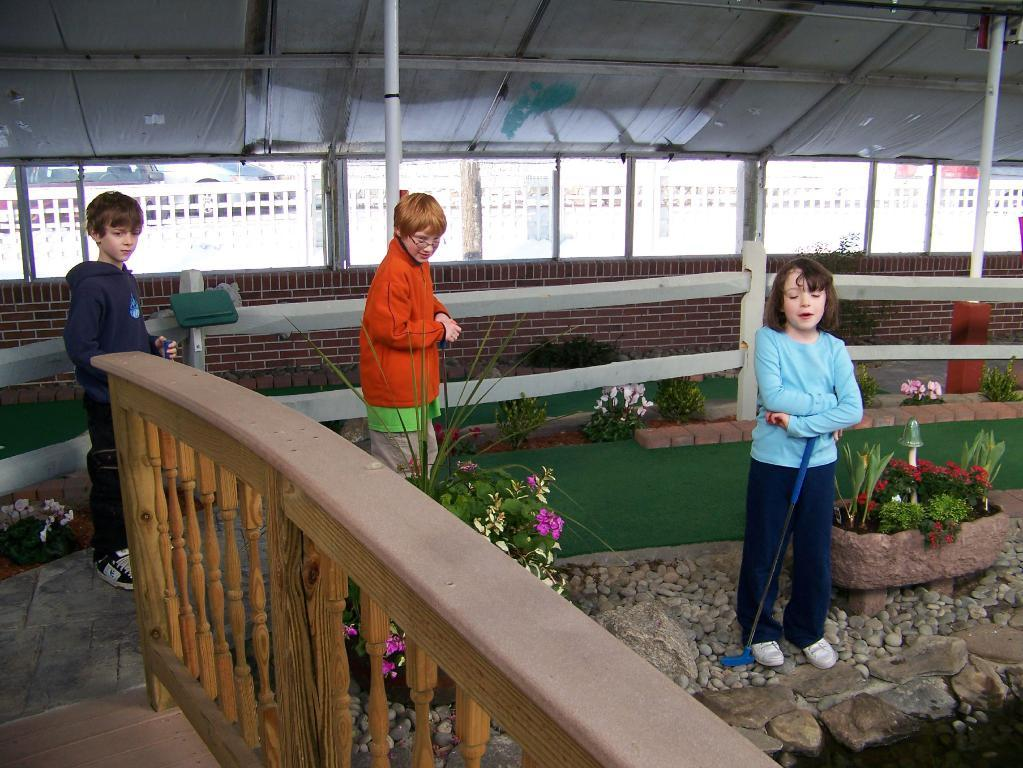How many children are in the image? There are three children in the image: two boys and a girl. What are the children doing in the image? The children are standing beside a wooden fence. What can be seen in the background of the image? There are plants, grass, and a shed in the background of the image. What type of butter is being used to cook on the stove in the image? There is no butter or stove present in the image. Can you see a zebra in the background of the image? No, there is no zebra in the image; it features three children standing beside a wooden fence with a background of plants, grass, and a shed. 